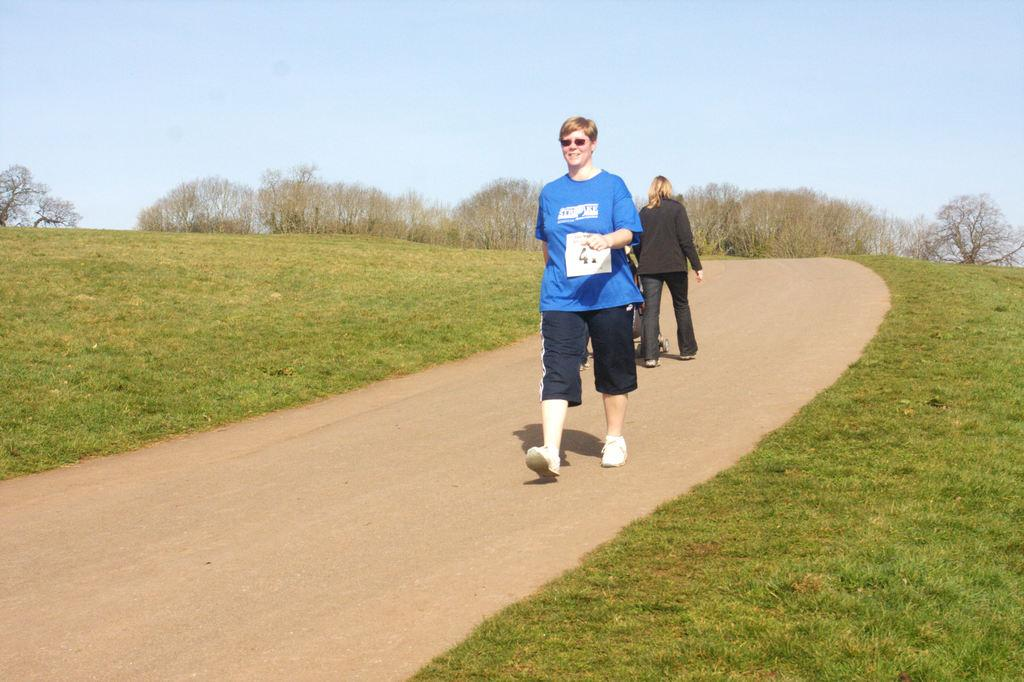What are the two people in the image doing? The two people in the image are walking. Can you describe what one of the people is carrying? One person is holding a baby carrier. What type of surface are the people walking on? There is a pathway in the image. What can be seen growing in the image? There is grass visible in the image. What type of vegetation is present in the image? There is a group of trees in the image. What is visible above the people and trees in the image? The sky is visible in the image. What type of toothpaste is being used by the person holding the baby carrier in the image? There is no toothpaste present in the image, and it is not mentioned that anyone is using toothpaste. 